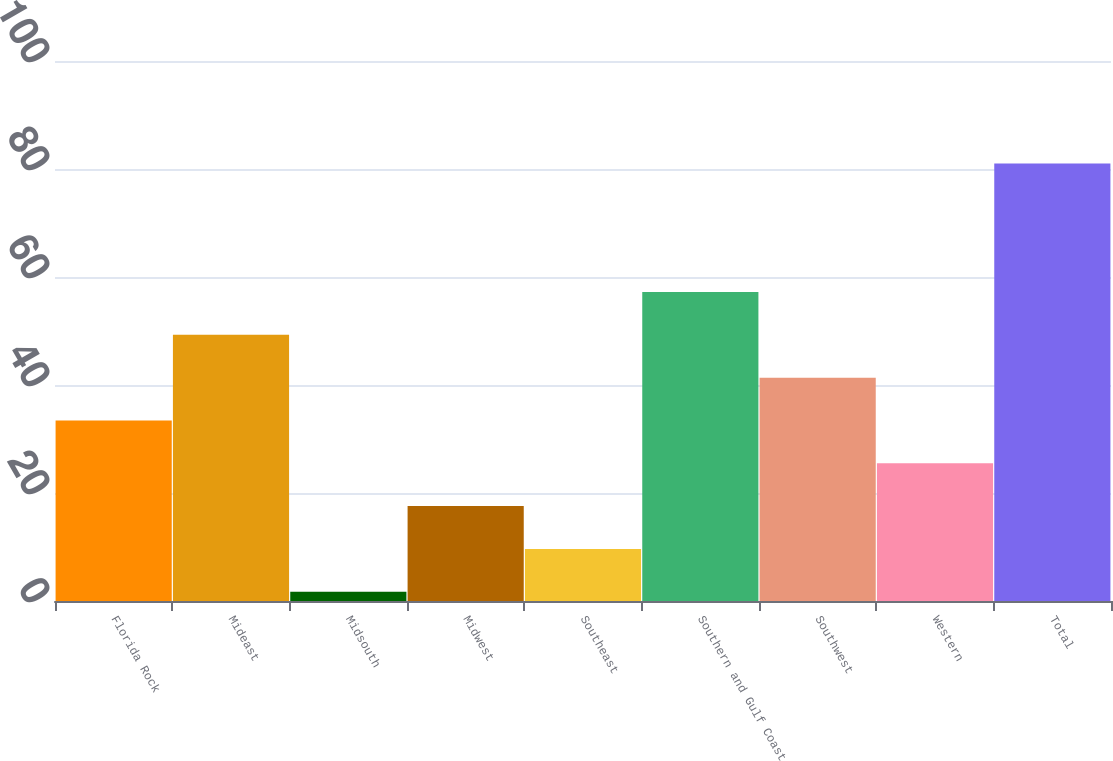<chart> <loc_0><loc_0><loc_500><loc_500><bar_chart><fcel>Florida Rock<fcel>Mideast<fcel>Midsouth<fcel>Midwest<fcel>Southeast<fcel>Southern and Gulf Coast<fcel>Southwest<fcel>Western<fcel>Total<nl><fcel>33.43<fcel>49.29<fcel>1.71<fcel>17.57<fcel>9.64<fcel>57.22<fcel>41.36<fcel>25.5<fcel>81<nl></chart> 